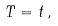<formula> <loc_0><loc_0><loc_500><loc_500>T = t \, , \\</formula> 